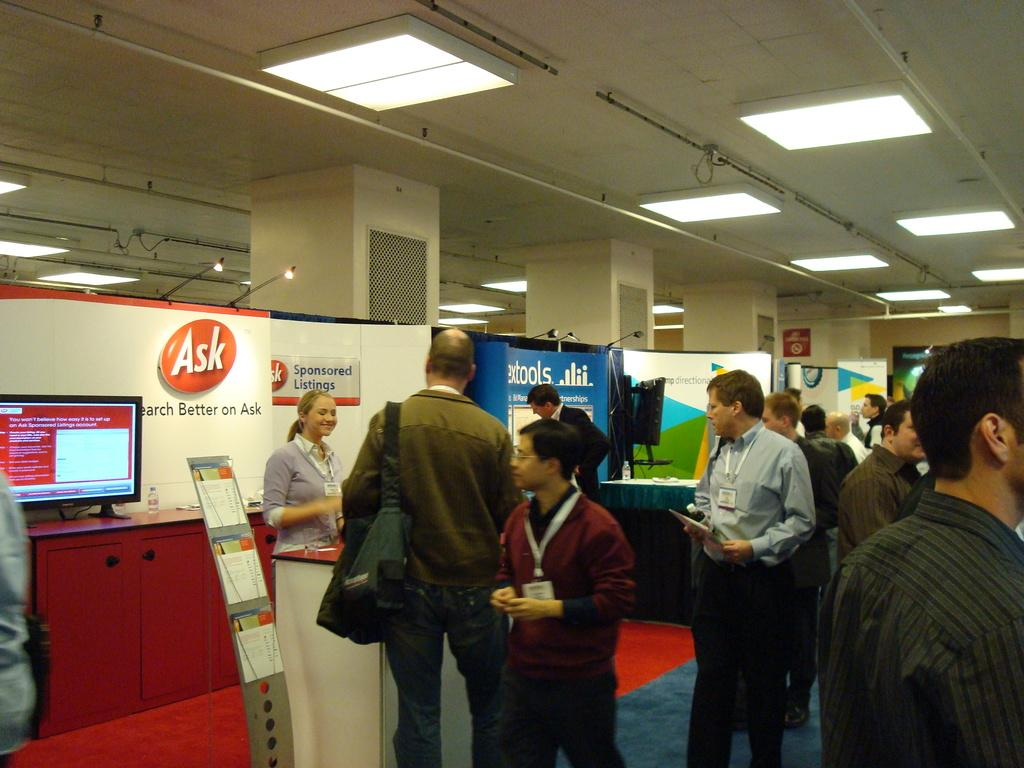What type of lighting is present in the image? There are electric lights in the image. What can be seen in the image that is used for cooking? There are grills in the image. What electronic devices are visible in the image? There are computers in the image. What type of containers are present in the image? There are disposal bottles in the image. What type of storage furniture is visible in the image? There are cupboards in the image. What is the condition of the floor in the image? There are persons on the floor in the image. Can you see a mask hanging on the wall in the image? There is no mask present in the image. Are there any trees visible in the image? There are no trees present in the image. 